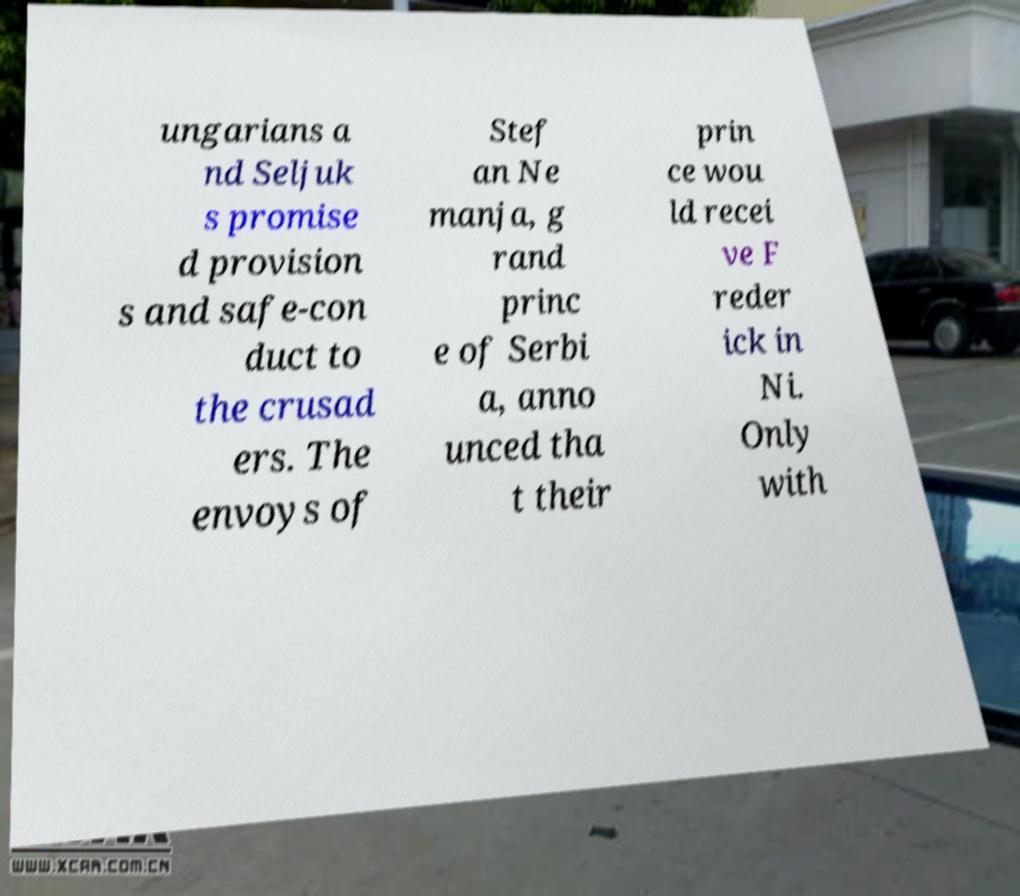Please identify and transcribe the text found in this image. ungarians a nd Seljuk s promise d provision s and safe-con duct to the crusad ers. The envoys of Stef an Ne manja, g rand princ e of Serbi a, anno unced tha t their prin ce wou ld recei ve F reder ick in Ni. Only with 